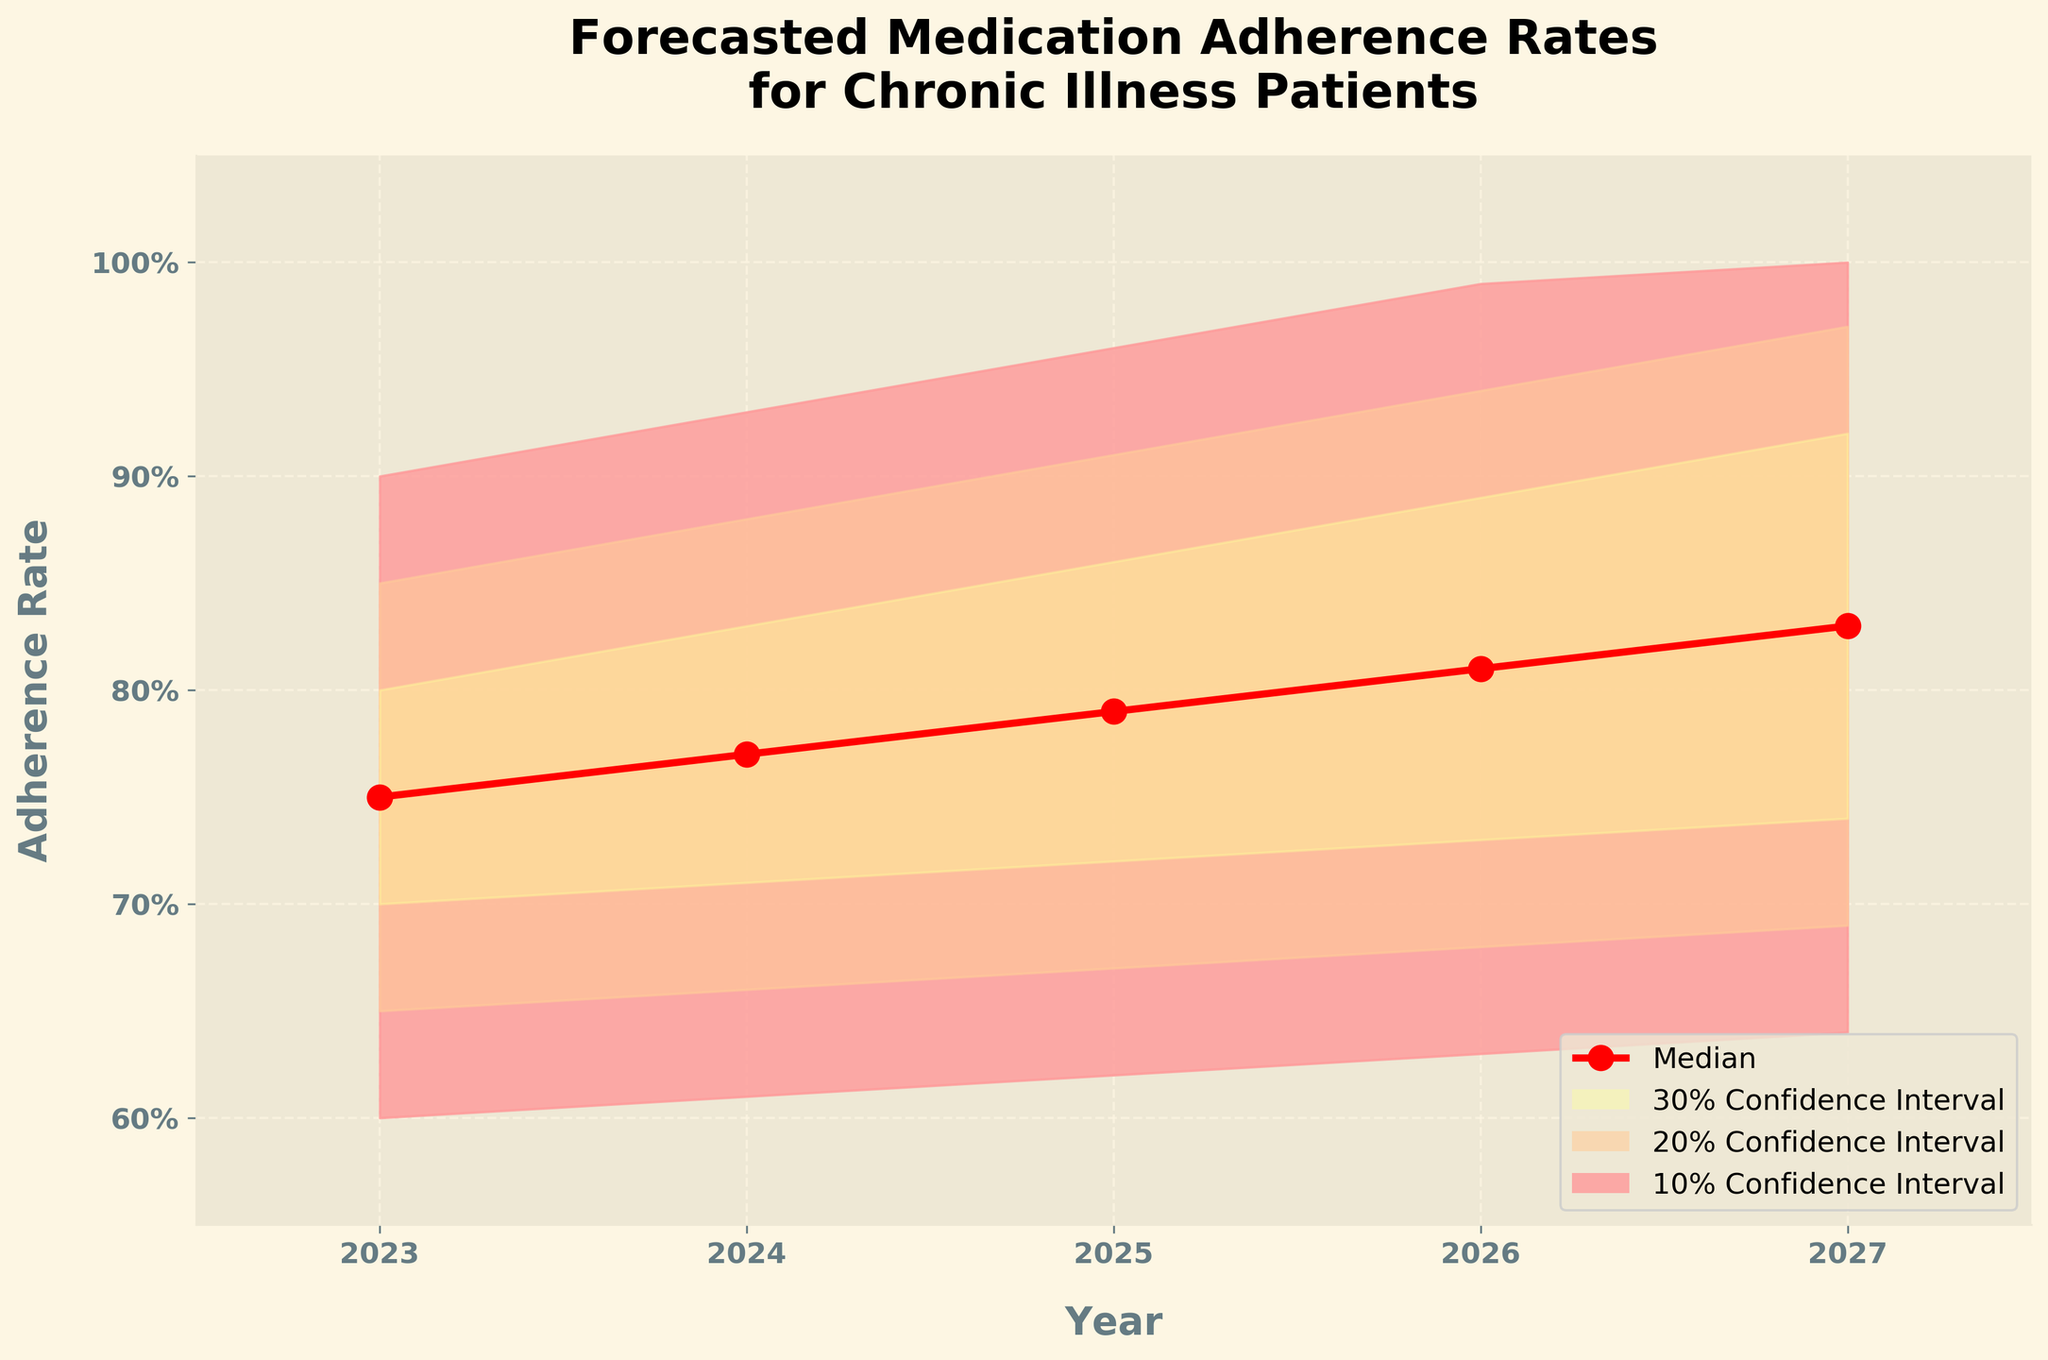What is the title of the chart? The title of the chart can be found at the top of the figure, which reads "Forecasted Medication Adherence Rates\nfor Chronic Illness Patients".
Answer: Forecasted Medication Adherence Rates\nfor Chronic Illness Patients What are the years covered in the forecast? The x-axis shows the years, ranging from 2023 to 2027. These are the forecasted years.
Answer: 2023 to 2027 What is the median adherence rate in 2025? Look at the red line (which indicates the median) at the year 2025 on the x-axis. The corresponding y-axis value is 79%.
Answer: 79% How does the median adherence rate change from 2023 to 2027? Follow the red line for the median values from 2023 to 2027: 75% in 2023, 77% in 2024, 79% in 2025, 81% in 2026, and 83% in 2027. The median adherence rate steadily increases over the years.
Answer: Increases What is the range of estimated adherence rates (30% confidence interval) for 2026? The 30% confidence interval is represented by the outermost shaded area. For 2026, the lower boundary (Low_30) is 63%, and the upper boundary (High_30) is 99%.
Answer: 63% to 99% How wide is the 10% confidence interval in 2024? The 10% confidence interval is the innermost shaded area. For 2024, subtract Low_10 (71%) from High_10 (83%): 83% - 71% = 12%.
Answer: 12% Which year has the highest median adherence rate? The red line indicates median adherence rates. It reaches the highest value in 2027 at 83%.
Answer: 2027 What is the smallest adherence rate forecast within the 20% confidence interval for 2025? The 20% confidence interval is the middle shaded area. For 2025, the lower boundary is represented by Low_20, which is 67%.
Answer: 67% Are the confidence intervals wider at the beginning or the end of the forecast period? Observe the width of shaded areas over the years. The intervals are wider towards the end (2027) compared to the beginning (2023). This is visually apparent, as the shaded areas expand over time.
Answer: The end What trends do you notice in the median adherence rate and the confidence intervals? The median adherence rate (red line) increases steadily over the years. Meanwhile, the confidence intervals (shaded areas) also expand, indicating increasing uncertainty over time.
Answer: Increasing rate and widening intervals 